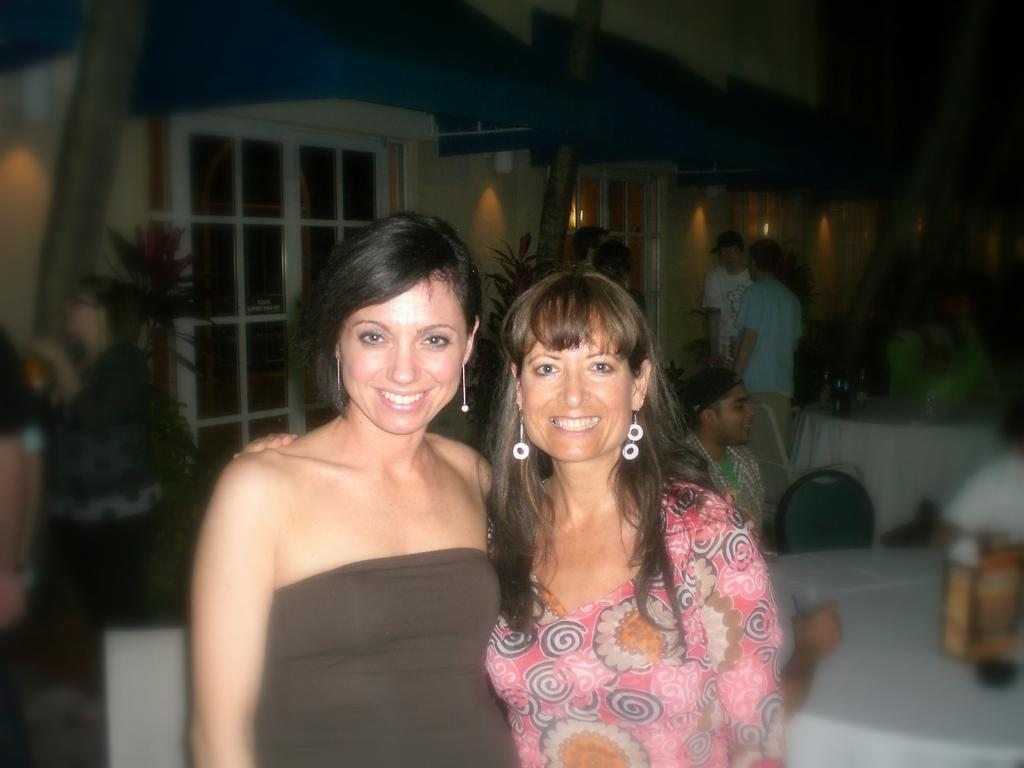How many women are in the image? There are two women in the image. What expression do the women have? The women are smiling. What can be seen in the background of the image? There is a table, people, house plants, and a wall in the background of the image. How many spiders are crawling on the window in the image? There is no window or spiders present in the image. What type of selection is available for the people in the background of the image? There is no indication of a selection or choice in the image; it only shows the women, the background elements, and the people in the background. 